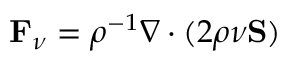<formula> <loc_0><loc_0><loc_500><loc_500>F _ { \nu } = \rho ^ { - 1 } \nabla \cdot ( 2 \rho \nu S )</formula> 